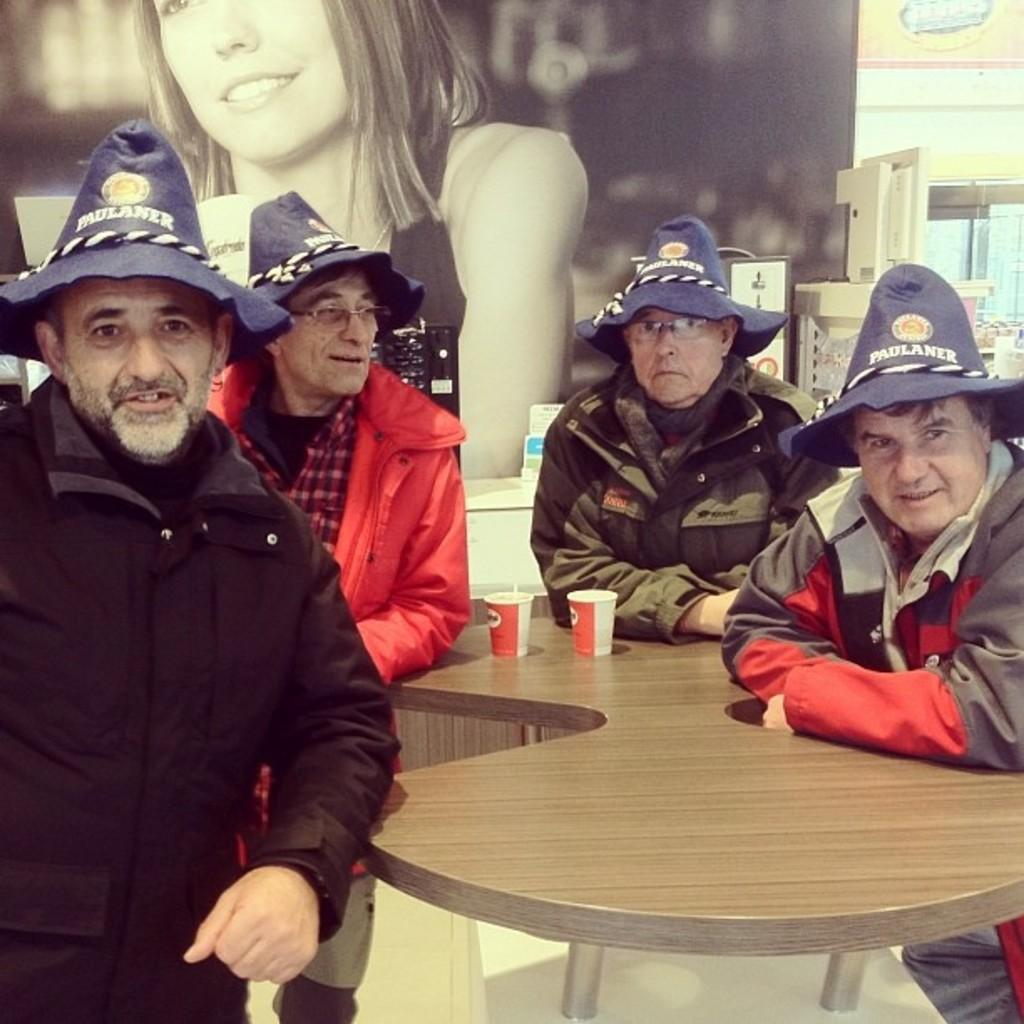How many people are in the image? There are four men in the image. What are the men wearing on their heads? All the men are wearing hats. What objects can be seen on the table in the image? There are two cups on a table in the image. What type of tree can be seen growing through the faucet in the image? There is no tree or faucet present in the image. 